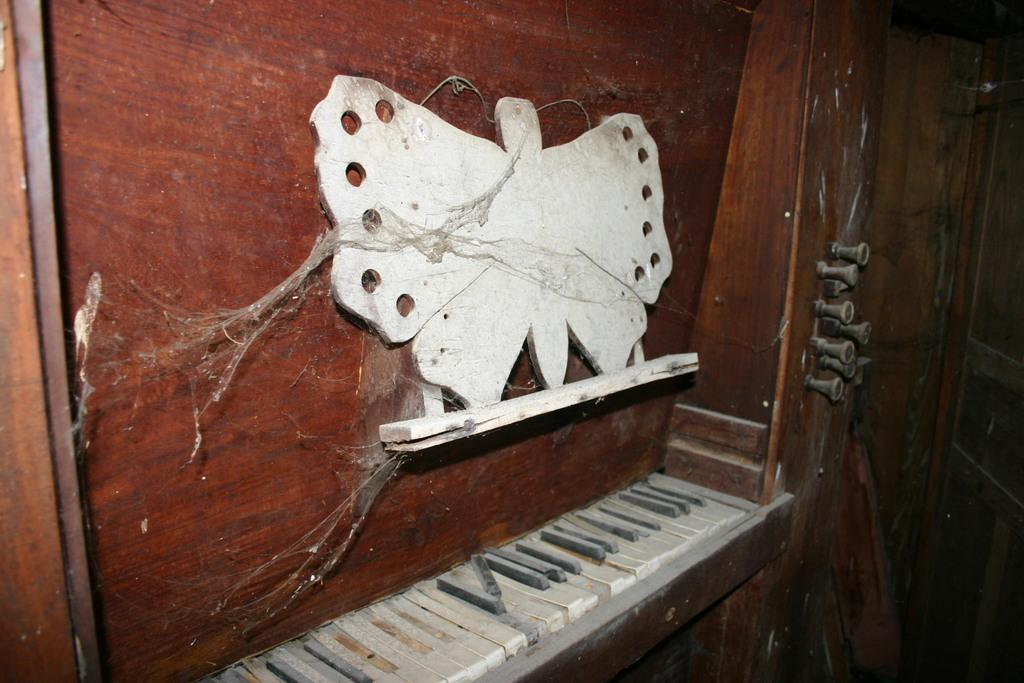What shape is the wooden frame in the image? The wooden frame in the image is in the shape of a butterfly. How is the wooden frame attached to the wall? The wooden frame is fixed to the wall. What other item can be seen in the image besides the wooden frame? Piano keys are visible in the image. What type of cap is the person wearing while attempting to improve the acoustics of the room in the image? There is no person wearing a cap or attempting to improve the acoustics of the room in the image; it only features a wooden frame in the shape of a butterfly and piano keys. 